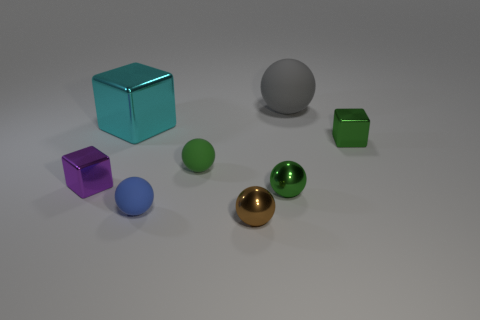There is a cube that is right of the large metallic thing; is there a cyan metallic cube that is in front of it?
Give a very brief answer. No. How many cylinders are either cyan metal objects or small green matte things?
Your answer should be compact. 0. Are there any purple objects that have the same shape as the blue rubber thing?
Offer a very short reply. No. The large cyan thing is what shape?
Offer a terse response. Cube. What number of things are either cyan objects or tiny cyan metallic spheres?
Your response must be concise. 1. Is the size of the shiny sphere behind the blue matte object the same as the blue thing that is in front of the large gray object?
Offer a very short reply. Yes. How many other objects are there of the same material as the big ball?
Offer a terse response. 2. Is the number of big cyan shiny objects to the left of the tiny purple shiny object greater than the number of tiny things on the right side of the large gray rubber ball?
Offer a very short reply. No. What is the block right of the cyan shiny thing made of?
Provide a short and direct response. Metal. Is the shape of the gray matte object the same as the brown shiny thing?
Provide a short and direct response. Yes. 